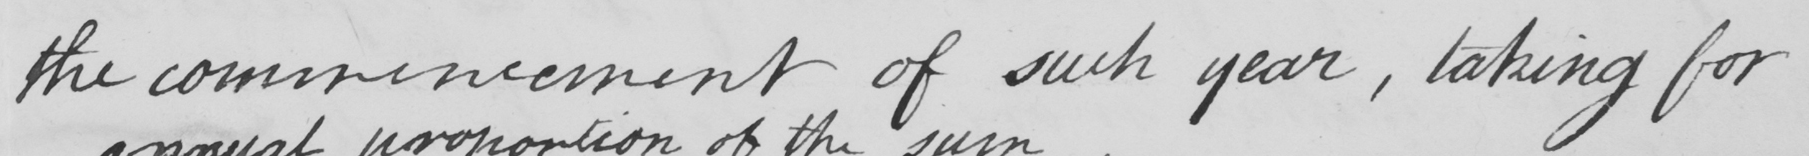Transcribe the text shown in this historical manuscript line. the commencement of such year , taking for 